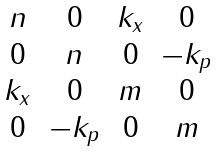<formula> <loc_0><loc_0><loc_500><loc_500>\begin{matrix} n & 0 & k _ { x } & 0 \\ 0 & n & 0 & - k _ { p } \\ k _ { x } & 0 & m & 0 \\ 0 & - k _ { p } & 0 & m \\ \end{matrix}</formula> 